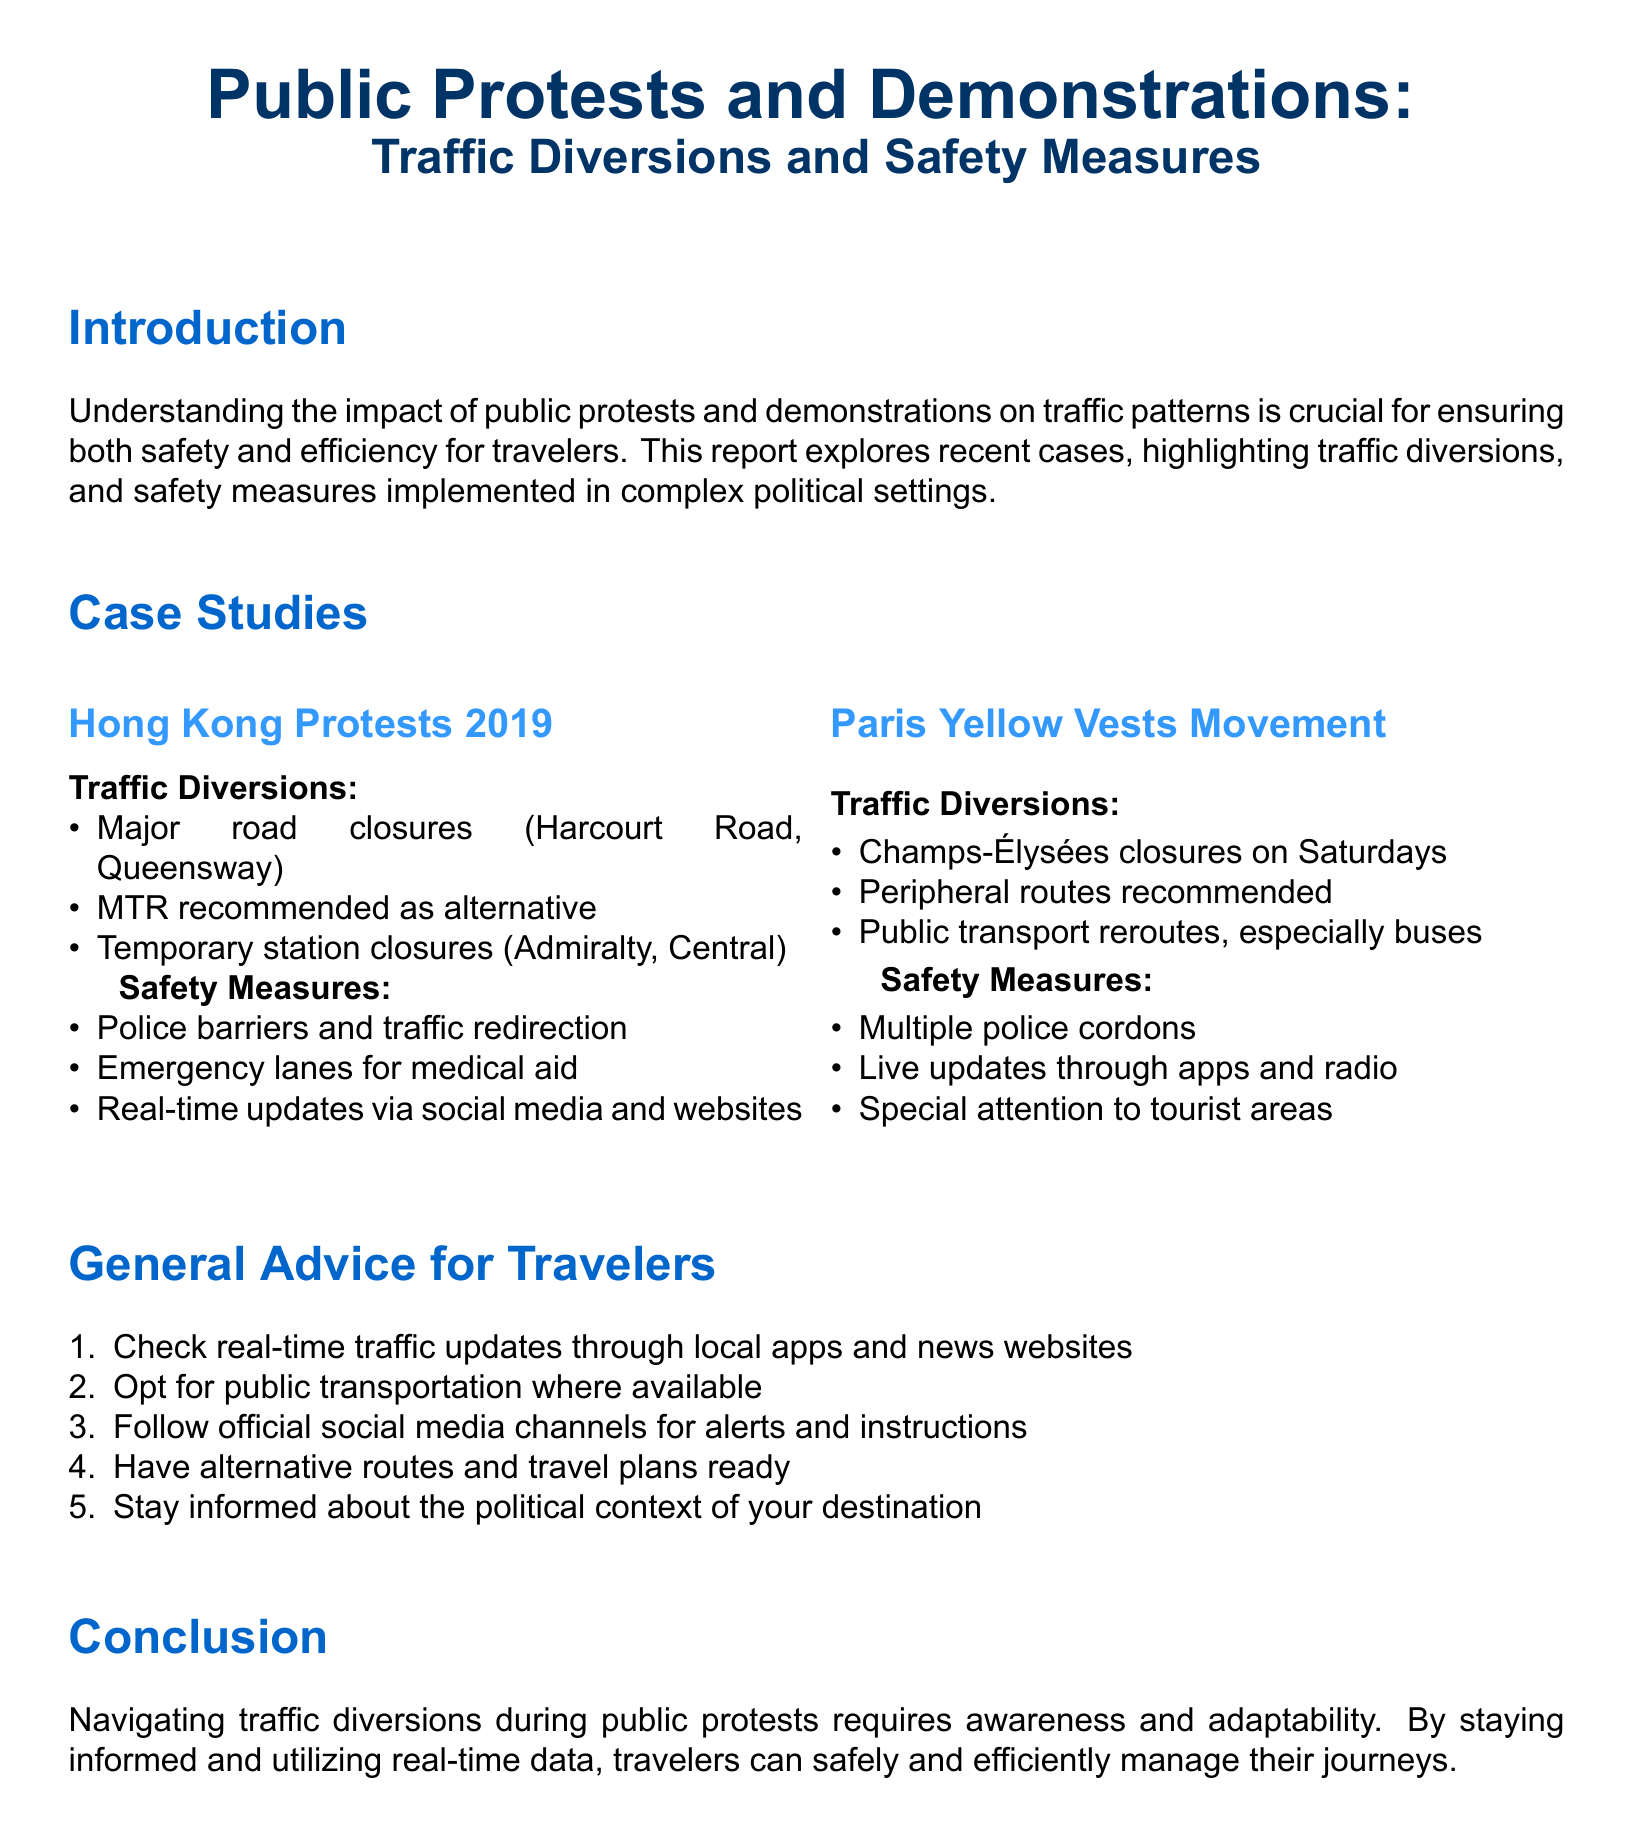what are the major road closures in Hong Kong? The major road closures listed in the document are Harcourt Road and Queensway during the Hong Kong protests.
Answer: Harcourt Road, Queensway what transportation alternative is recommended in Hong Kong? The document suggests using MTR as an alternative mode of transportation during the protests.
Answer: MTR how are tourists kept informed during the Paris protests? Tourists receive live updates through apps and radio as part of the safety measures during the Paris protests.
Answer: Live updates through apps and radio what safety measure is implemented in both case studies? Both case studies include the use of police barriers and traffic redirection to ensure safety during protests.
Answer: Police barriers and traffic redirection what is a general piece of advice for travelers during protests? Travelers are advised to check real-time traffic updates through local apps and news websites for information during protests.
Answer: Check real-time traffic updates how many case studies are included in the document? The document includes two case studies: one on Hong Kong and one on Paris.
Answer: Two what special routes are recommended during the Yellow Vests Movement? The document recommends using peripheral routes during the Yellow Vests Movement in Paris.
Answer: Peripheral routes what is a recommended action after checking for real-time updates? It is suggested that travelers should have alternative routes and travel plans ready in case of traffic diversions.
Answer: Have alternative routes and travel plans ready what is essential to stay informed about while traveling? The document highlights the importance of staying informed about the political context of your destination while traveling.
Answer: Political context of your destination 